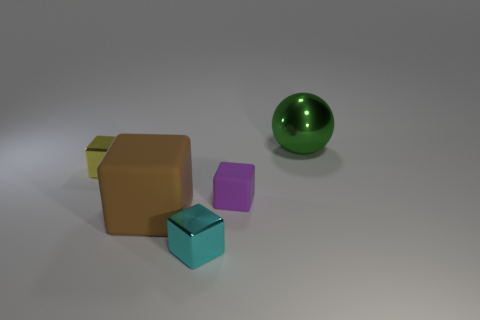How many metal things are in front of the block that is behind the tiny rubber object?
Make the answer very short. 1. Is there any other thing that has the same material as the sphere?
Give a very brief answer. Yes. What material is the large object on the left side of the small cube in front of the big object that is on the left side of the metal ball?
Your response must be concise. Rubber. There is a thing that is both to the right of the big cube and in front of the small purple thing; what material is it?
Give a very brief answer. Metal. How many big matte objects have the same shape as the tiny matte object?
Give a very brief answer. 1. There is a matte block left of the small metallic object that is in front of the yellow shiny block; what is its size?
Keep it short and to the point. Large. There is a metallic thing left of the cyan thing; does it have the same color as the small shiny thing that is in front of the brown thing?
Provide a succinct answer. No. There is a sphere to the right of the metal thing that is left of the brown cube; what number of large green metal things are in front of it?
Your answer should be very brief. 0. How many objects are to the right of the cyan shiny object and on the left side of the shiny sphere?
Offer a very short reply. 1. Is the number of brown things to the left of the tiny yellow block greater than the number of tiny yellow objects?
Offer a terse response. No. 